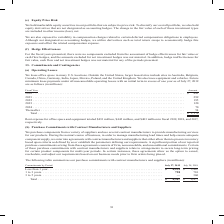According to Cisco Systems's financial document, How does the company provide manufacturing services for their products? purchase components from a variety of suppliers and use several contract manufacturers. The document states: "We purchase components from a variety of suppliers and use several contract manufacturers to provide manufacturing services for our products� During t..." Also, What were the purchase commitments with commitments that were 1 to 3 years in 2019? According to the financial document, 728 (in millions). The relevant text states: "� � � � � � � � � � � � � � � � � � � � � � � � � 728 710 3 to 5 years� � � � � � � � � � � � � � � � � � � � � � � � � � � � � � � � � � � � � � � � � �..." Also, What were the purchase commitments with commitments that were 3 to 5 years in 2018? According to the financial document, 360 (in millions). The relevant text states: "� � � � � � � � � � � � � � � � � � � � � � � � — 360 Total � � � � � � � � � � � � � � � � � � � � � � � � � � � � � � � � � � � � � � � � � � � � � � �..." Also, can you calculate: What was the percentage change in total purchase commitments between 2018 and 2019? To answer this question, I need to perform calculations using the financial data. The calculation is: (4,967-6,477)/6,477, which equals -23.31 (percentage). This is based on the information: "� � � � � � � � � � � � � � � � � � � � $ 4,967 $ 6,477 � � � � � � � � � � � � � � � � � � � � � � � � $ 4,967 $ 6,477..." The key data points involved are: 4,967, 6,477. Also, How many years did total purchase commitments exceed $5,000 million? Based on the analysis, there are 1 instances. The counting process: 2018. Also, can you calculate: What was the change in the amount of purchase commitments for commitments that were less than 1 year between 2018 and 2019? Based on the calculation: 4,239-5,407, the result is -1168 (in millions). This is based on the information: "� � � � � � � � � � � � � � � � � � � � $ 4,239 $ 5,407 1 to 3 years� � � � � � � � � � � � � � � � � � � � � � � � � � � � � � � � � � � � � � � � � � � � � � � � � � � � � � � � � � � � � � � � � � ..." The key data points involved are: 4,239, 5,407. 